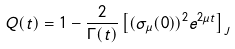Convert formula to latex. <formula><loc_0><loc_0><loc_500><loc_500>Q ( t ) = 1 - \frac { 2 } { \Gamma ( t ) } \left [ ( \sigma _ { \mu } ( 0 ) ) ^ { 2 } e ^ { 2 \mu t } \right ] _ { J }</formula> 